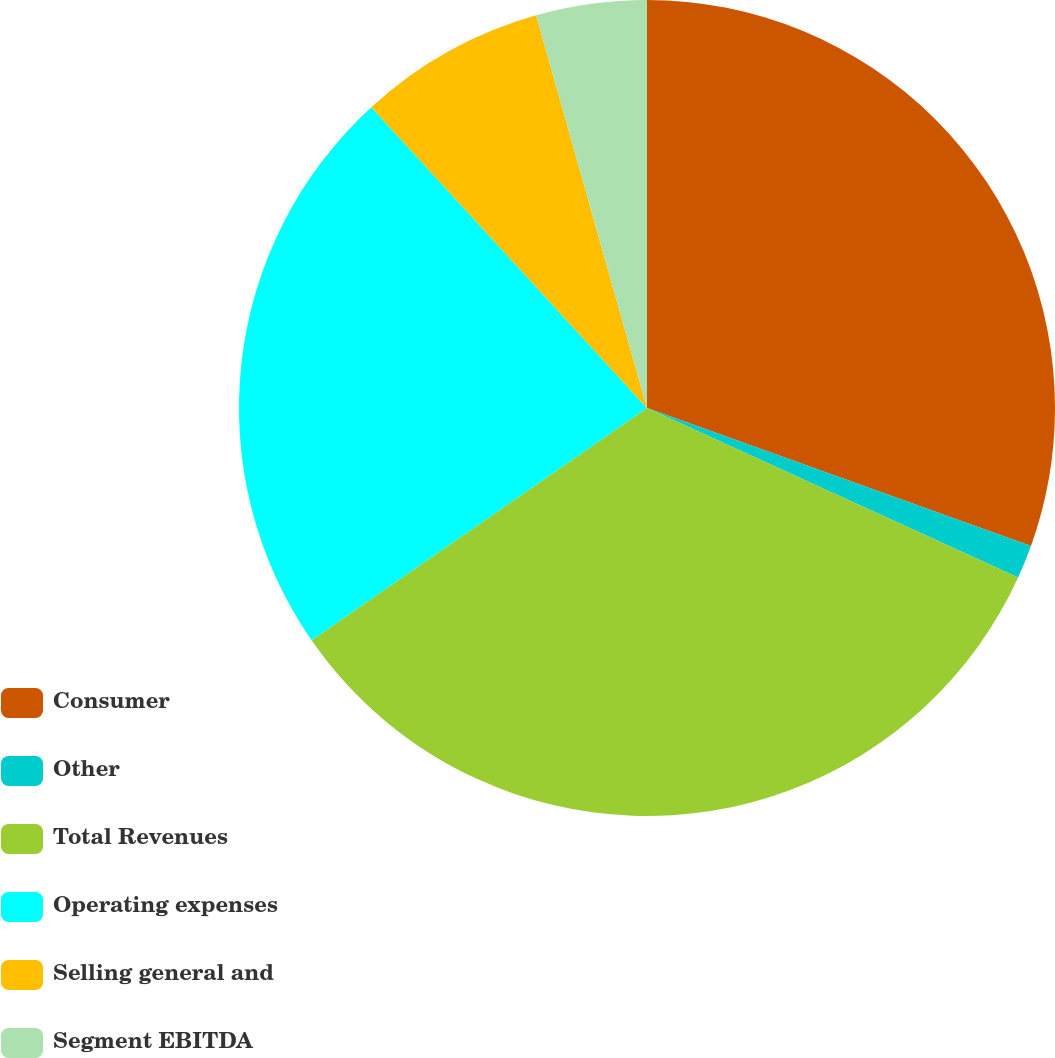<chart> <loc_0><loc_0><loc_500><loc_500><pie_chart><fcel>Consumer<fcel>Other<fcel>Total Revenues<fcel>Operating expenses<fcel>Selling general and<fcel>Segment EBITDA<nl><fcel>30.49%<fcel>1.33%<fcel>33.54%<fcel>22.83%<fcel>7.43%<fcel>4.38%<nl></chart> 